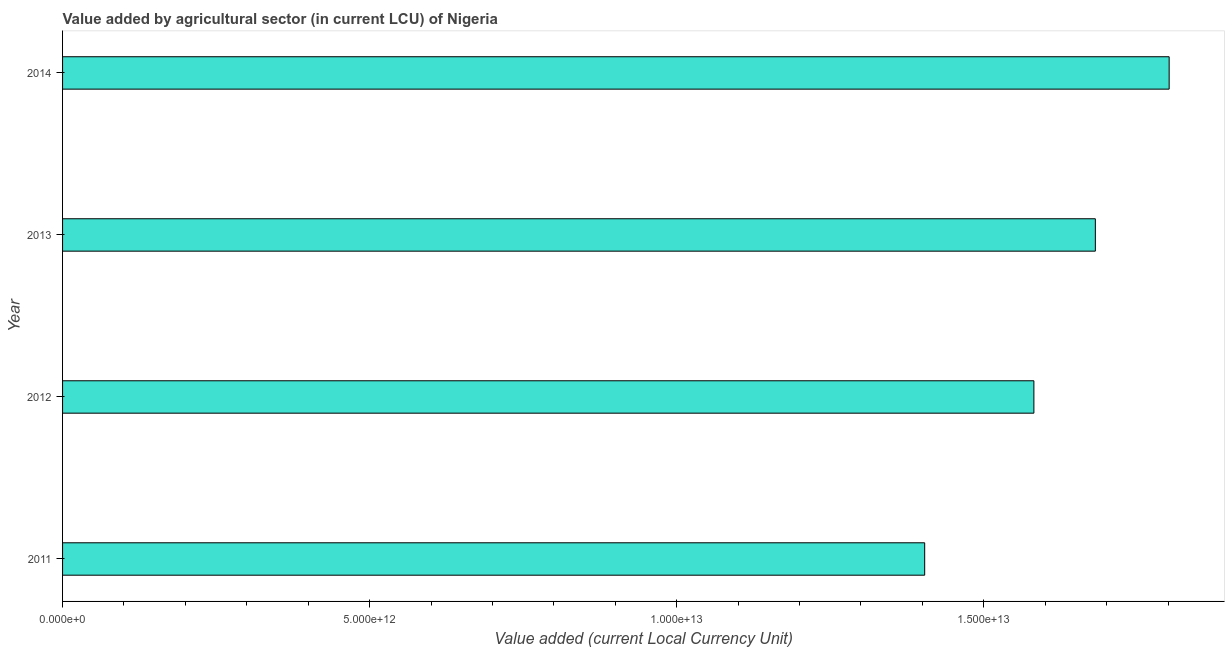Does the graph contain any zero values?
Your answer should be very brief. No. What is the title of the graph?
Your response must be concise. Value added by agricultural sector (in current LCU) of Nigeria. What is the label or title of the X-axis?
Provide a short and direct response. Value added (current Local Currency Unit). What is the value added by agriculture sector in 2011?
Provide a short and direct response. 1.40e+13. Across all years, what is the maximum value added by agriculture sector?
Make the answer very short. 1.80e+13. Across all years, what is the minimum value added by agriculture sector?
Offer a terse response. 1.40e+13. In which year was the value added by agriculture sector maximum?
Keep it short and to the point. 2014. What is the sum of the value added by agriculture sector?
Keep it short and to the point. 6.47e+13. What is the difference between the value added by agriculture sector in 2012 and 2013?
Ensure brevity in your answer.  -1.00e+12. What is the average value added by agriculture sector per year?
Keep it short and to the point. 1.62e+13. What is the median value added by agriculture sector?
Make the answer very short. 1.63e+13. Do a majority of the years between 2011 and 2012 (inclusive) have value added by agriculture sector greater than 13000000000000 LCU?
Make the answer very short. Yes. What is the ratio of the value added by agriculture sector in 2012 to that in 2013?
Keep it short and to the point. 0.94. What is the difference between the highest and the second highest value added by agriculture sector?
Ensure brevity in your answer.  1.20e+12. What is the difference between the highest and the lowest value added by agriculture sector?
Your answer should be compact. 3.98e+12. In how many years, is the value added by agriculture sector greater than the average value added by agriculture sector taken over all years?
Offer a terse response. 2. Are all the bars in the graph horizontal?
Your answer should be very brief. Yes. What is the difference between two consecutive major ticks on the X-axis?
Provide a succinct answer. 5.00e+12. Are the values on the major ticks of X-axis written in scientific E-notation?
Your response must be concise. Yes. What is the Value added (current Local Currency Unit) in 2011?
Make the answer very short. 1.40e+13. What is the Value added (current Local Currency Unit) of 2012?
Ensure brevity in your answer.  1.58e+13. What is the Value added (current Local Currency Unit) of 2013?
Provide a short and direct response. 1.68e+13. What is the Value added (current Local Currency Unit) of 2014?
Your response must be concise. 1.80e+13. What is the difference between the Value added (current Local Currency Unit) in 2011 and 2012?
Provide a short and direct response. -1.78e+12. What is the difference between the Value added (current Local Currency Unit) in 2011 and 2013?
Ensure brevity in your answer.  -2.78e+12. What is the difference between the Value added (current Local Currency Unit) in 2011 and 2014?
Provide a short and direct response. -3.98e+12. What is the difference between the Value added (current Local Currency Unit) in 2012 and 2013?
Your answer should be compact. -1.00e+12. What is the difference between the Value added (current Local Currency Unit) in 2012 and 2014?
Provide a short and direct response. -2.20e+12. What is the difference between the Value added (current Local Currency Unit) in 2013 and 2014?
Provide a short and direct response. -1.20e+12. What is the ratio of the Value added (current Local Currency Unit) in 2011 to that in 2012?
Provide a succinct answer. 0.89. What is the ratio of the Value added (current Local Currency Unit) in 2011 to that in 2013?
Make the answer very short. 0.83. What is the ratio of the Value added (current Local Currency Unit) in 2011 to that in 2014?
Your answer should be compact. 0.78. What is the ratio of the Value added (current Local Currency Unit) in 2012 to that in 2013?
Make the answer very short. 0.94. What is the ratio of the Value added (current Local Currency Unit) in 2012 to that in 2014?
Provide a short and direct response. 0.88. What is the ratio of the Value added (current Local Currency Unit) in 2013 to that in 2014?
Give a very brief answer. 0.93. 